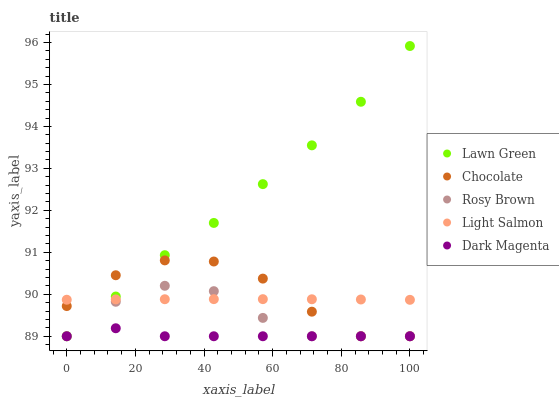Does Dark Magenta have the minimum area under the curve?
Answer yes or no. Yes. Does Lawn Green have the maximum area under the curve?
Answer yes or no. Yes. Does Light Salmon have the minimum area under the curve?
Answer yes or no. No. Does Light Salmon have the maximum area under the curve?
Answer yes or no. No. Is Light Salmon the smoothest?
Answer yes or no. Yes. Is Chocolate the roughest?
Answer yes or no. Yes. Is Rosy Brown the smoothest?
Answer yes or no. No. Is Rosy Brown the roughest?
Answer yes or no. No. Does Lawn Green have the lowest value?
Answer yes or no. Yes. Does Light Salmon have the lowest value?
Answer yes or no. No. Does Lawn Green have the highest value?
Answer yes or no. Yes. Does Light Salmon have the highest value?
Answer yes or no. No. Is Dark Magenta less than Light Salmon?
Answer yes or no. Yes. Is Light Salmon greater than Dark Magenta?
Answer yes or no. Yes. Does Lawn Green intersect Rosy Brown?
Answer yes or no. Yes. Is Lawn Green less than Rosy Brown?
Answer yes or no. No. Is Lawn Green greater than Rosy Brown?
Answer yes or no. No. Does Dark Magenta intersect Light Salmon?
Answer yes or no. No. 